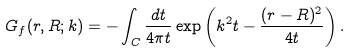Convert formula to latex. <formula><loc_0><loc_0><loc_500><loc_500>G _ { f } ( r , R ; k ) = - \int _ { C } \frac { d t } { 4 \pi t } \exp \left ( k ^ { 2 } t - \frac { ( r - R ) ^ { 2 } } { 4 t } \right ) .</formula> 